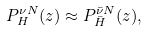Convert formula to latex. <formula><loc_0><loc_0><loc_500><loc_500>P ^ { \nu N } _ { H } ( z ) \approx P ^ { \bar { \nu } N } _ { \bar { H } } ( z ) ,</formula> 